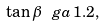Convert formula to latex. <formula><loc_0><loc_0><loc_500><loc_500>\tan \beta \, \ g a \, 1 . 2 ,</formula> 